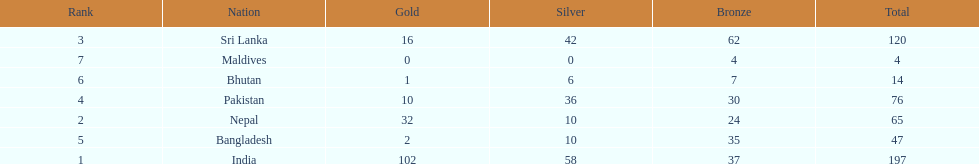What was the only nation to win less than 10 medals total? Maldives. 